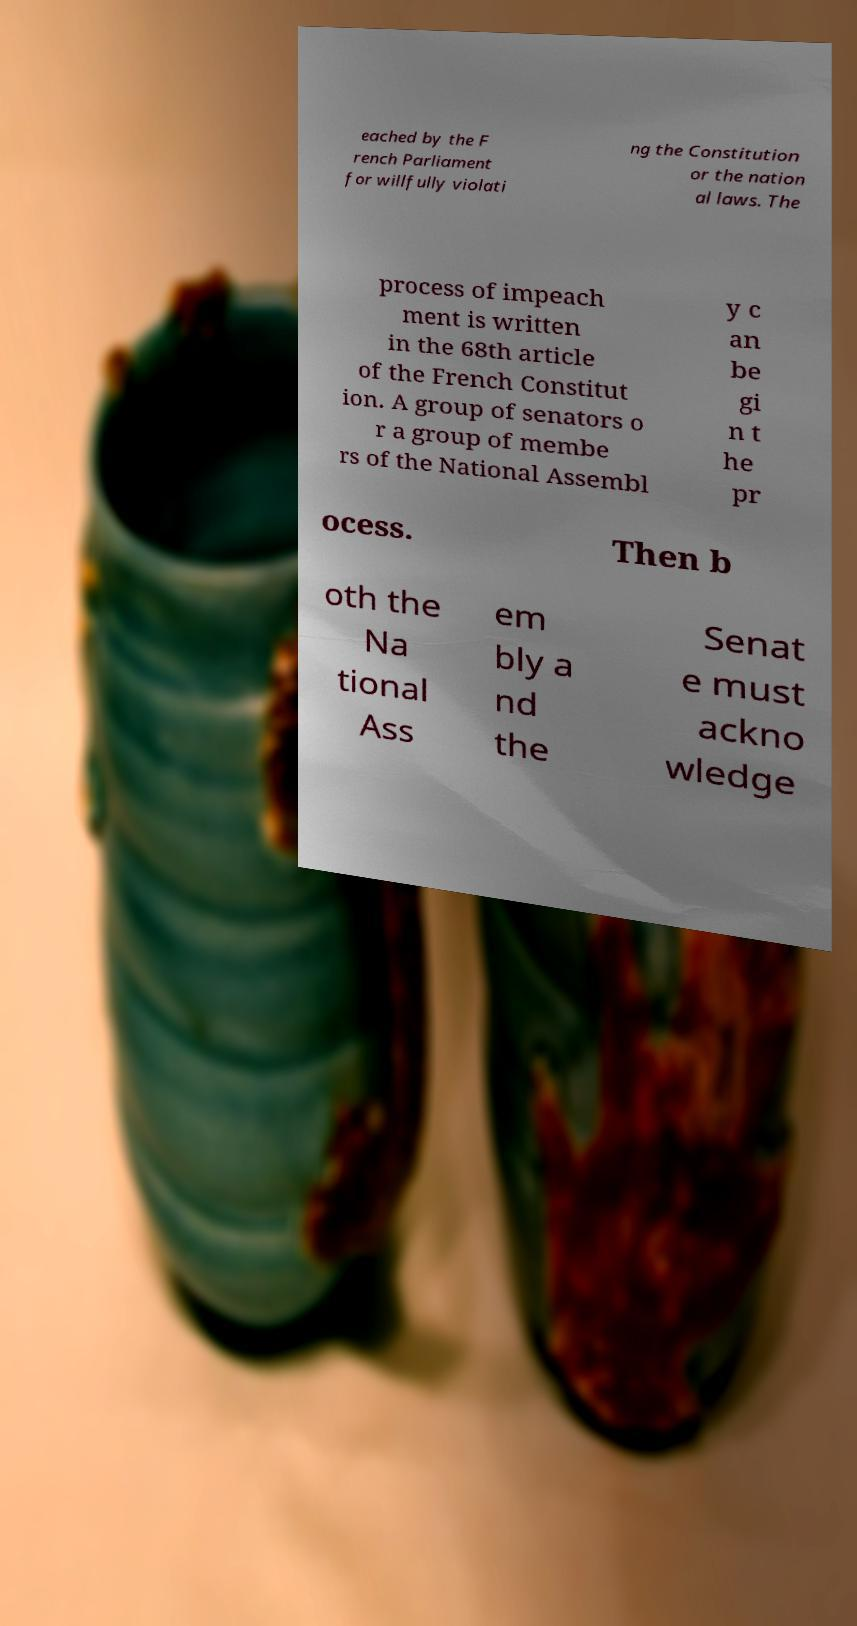I need the written content from this picture converted into text. Can you do that? eached by the F rench Parliament for willfully violati ng the Constitution or the nation al laws. The process of impeach ment is written in the 68th article of the French Constitut ion. A group of senators o r a group of membe rs of the National Assembl y c an be gi n t he pr ocess. Then b oth the Na tional Ass em bly a nd the Senat e must ackno wledge 